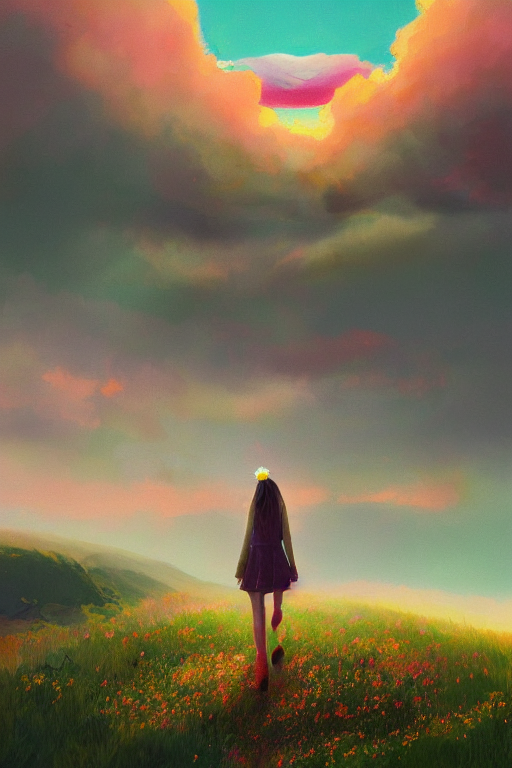What mood does this image evoke? This image evokes a mood of contemplation and tranquility. The solitary figure walking through the field of flowers, along with the vast, open sky and the gentle gradient of colors, creates a sense of peacefulness and introspection. 